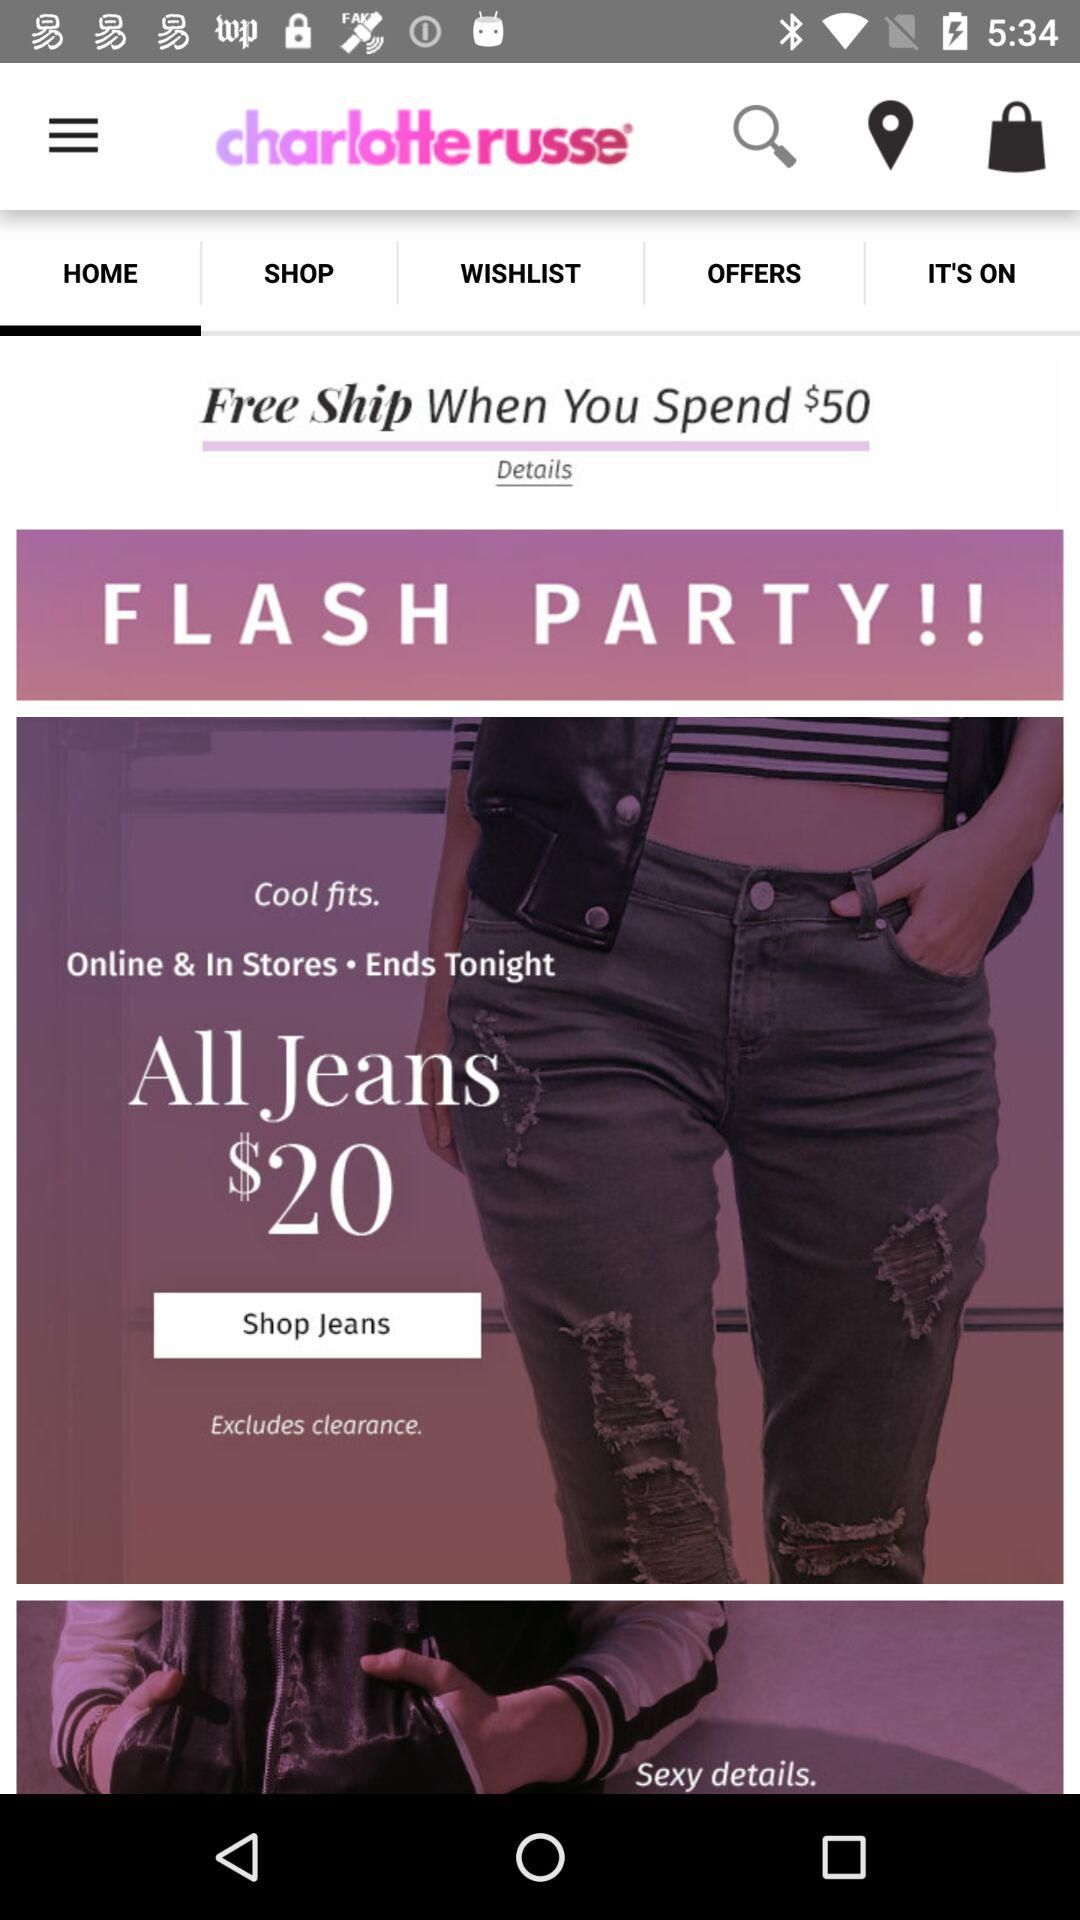How much do I need to spend to get free shipping?
Answer the question using a single word or phrase. $50 